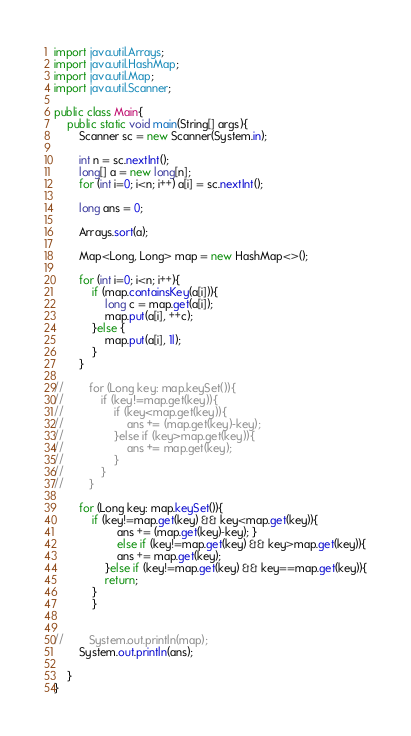Convert code to text. <code><loc_0><loc_0><loc_500><loc_500><_Java_>import java.util.Arrays;
import java.util.HashMap;
import java.util.Map;
import java.util.Scanner;

public class Main{
    public static void main(String[] args){
        Scanner sc = new Scanner(System.in);

        int n = sc.nextInt();
        long[] a = new long[n];
        for (int i=0; i<n; i++) a[i] = sc.nextInt();

        long ans = 0;

        Arrays.sort(a);

        Map<Long, Long> map = new HashMap<>();

        for (int i=0; i<n; i++){
            if (map.containsKey(a[i])){
                long c = map.get(a[i]);
                map.put(a[i], ++c);
            }else {
                map.put(a[i], 1l);
            }
        }

//        for (Long key: map.keySet()){
//            if (key!=map.get(key)){
//                if (key<map.get(key)){
//                    ans += (map.get(key)-key);
//                }else if (key>map.get(key)){
//                    ans += map.get(key);
//                }
//            }
//        }

        for (Long key: map.keySet()){
            if (key!=map.get(key) && key<map.get(key)){
                    ans += (map.get(key)-key); }
                    else if (key!=map.get(key) && key>map.get(key)){
                    ans += map.get(key);
                }else if (key!=map.get(key) && key==map.get(key)){
                return;
            }
            }


//        System.out.println(map);
        System.out.println(ans);

    }
}
</code> 